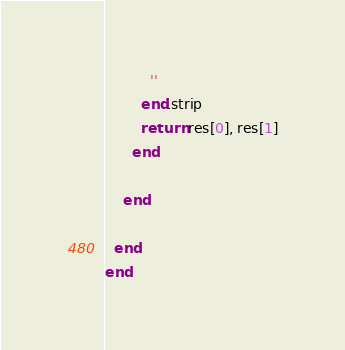<code> <loc_0><loc_0><loc_500><loc_500><_Ruby_>          ''
        end.strip
        return res[0], res[1]
      end

    end

  end
end</code> 